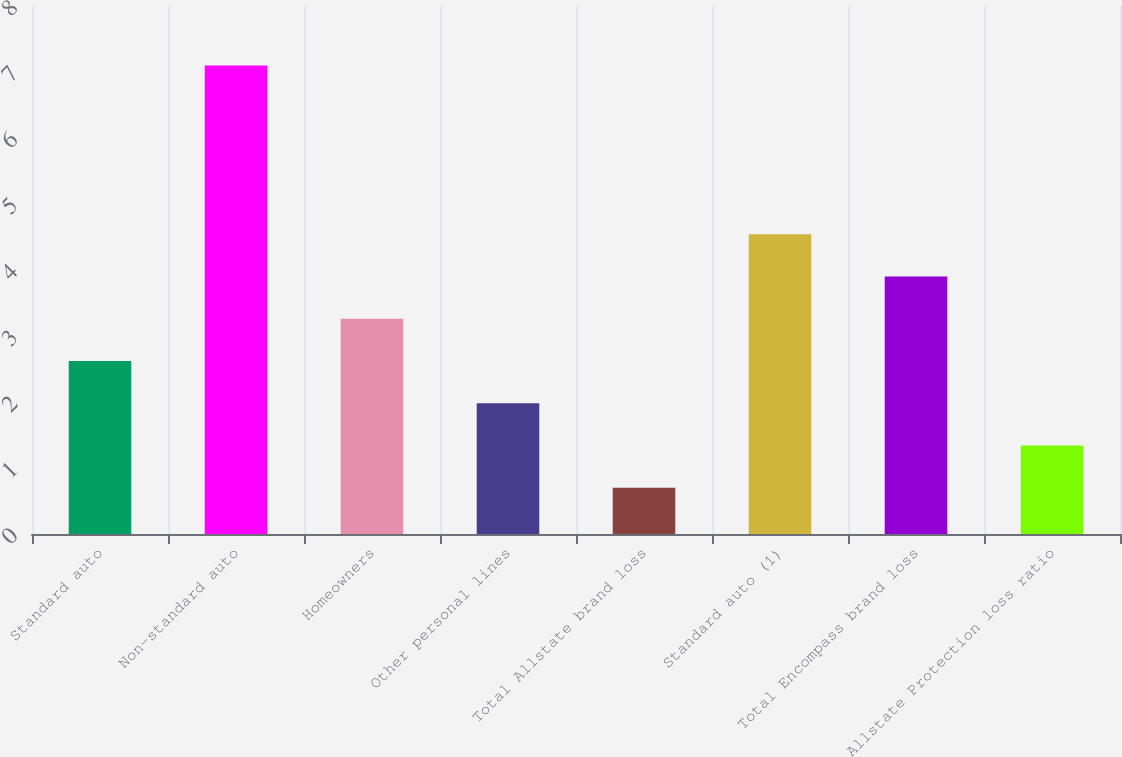Convert chart. <chart><loc_0><loc_0><loc_500><loc_500><bar_chart><fcel>Standard auto<fcel>Non-standard auto<fcel>Homeowners<fcel>Other personal lines<fcel>Total Allstate brand loss<fcel>Standard auto (1)<fcel>Total Encompass brand loss<fcel>Allstate Protection loss ratio<nl><fcel>2.62<fcel>7.1<fcel>3.26<fcel>1.98<fcel>0.7<fcel>4.54<fcel>3.9<fcel>1.34<nl></chart> 